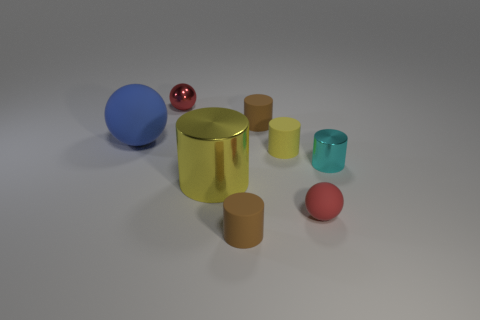What shape is the thing that is the same color as the small matte sphere?
Your answer should be very brief. Sphere. There is a object that is the same color as the tiny rubber ball; what is its size?
Provide a short and direct response. Small. Is the color of the small ball that is behind the big yellow shiny cylinder the same as the tiny matte ball?
Offer a very short reply. Yes. How many matte objects are left of the shiny ball and on the right side of the large blue ball?
Provide a short and direct response. 0. Are the cyan cylinder and the big blue thing made of the same material?
Your response must be concise. No. There is a red thing right of the tiny matte cylinder on the right side of the brown rubber cylinder behind the large rubber thing; what shape is it?
Keep it short and to the point. Sphere. What material is the small cylinder that is behind the large shiny thing and in front of the yellow rubber cylinder?
Offer a terse response. Metal. There is a large cylinder left of the brown object in front of the big thing that is in front of the blue matte sphere; what color is it?
Your answer should be compact. Yellow. What number of red things are either big objects or matte spheres?
Ensure brevity in your answer.  1. How many other things are the same size as the red metal object?
Your answer should be very brief. 5. 